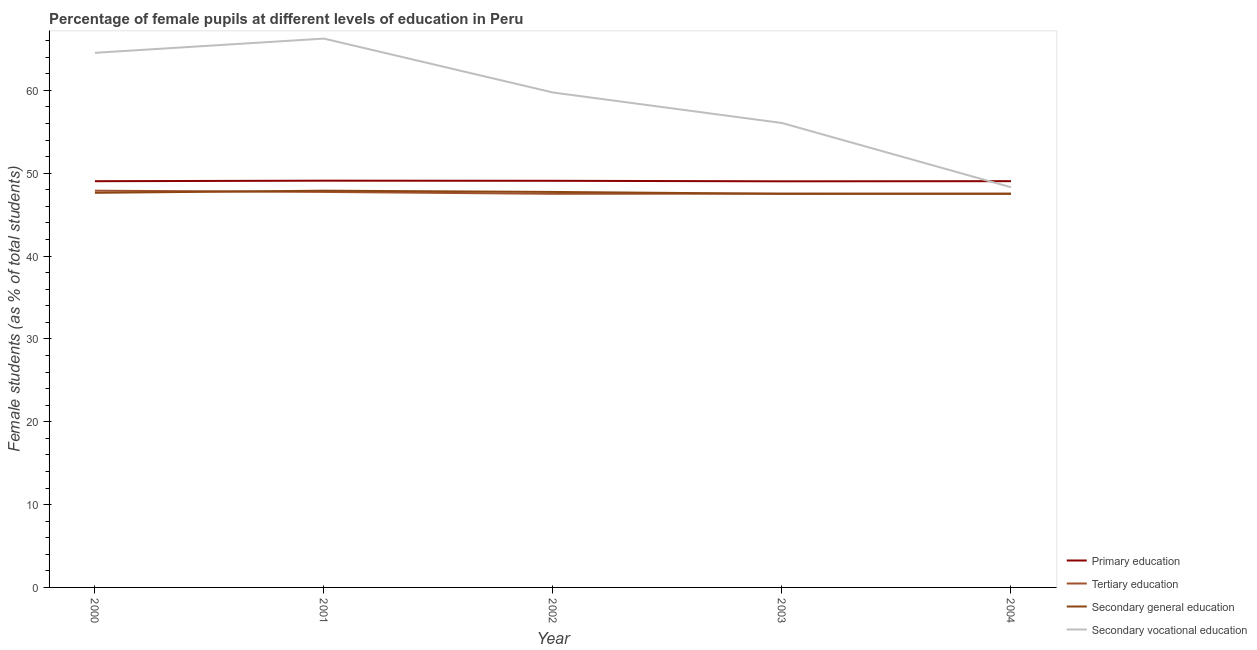What is the percentage of female students in primary education in 2003?
Keep it short and to the point. 49.02. Across all years, what is the maximum percentage of female students in secondary education?
Your answer should be compact. 47.89. Across all years, what is the minimum percentage of female students in tertiary education?
Your answer should be compact. 47.5. In which year was the percentage of female students in tertiary education maximum?
Offer a very short reply. 2000. What is the total percentage of female students in secondary education in the graph?
Provide a succinct answer. 238.3. What is the difference between the percentage of female students in secondary education in 2000 and that in 2003?
Make the answer very short. 0.12. What is the difference between the percentage of female students in tertiary education in 2000 and the percentage of female students in secondary vocational education in 2001?
Your answer should be compact. -18.36. What is the average percentage of female students in tertiary education per year?
Your response must be concise. 47.63. In the year 2002, what is the difference between the percentage of female students in secondary education and percentage of female students in secondary vocational education?
Your answer should be very brief. -12. What is the ratio of the percentage of female students in secondary education in 2001 to that in 2004?
Make the answer very short. 1.01. Is the percentage of female students in secondary education in 2001 less than that in 2002?
Keep it short and to the point. No. Is the difference between the percentage of female students in secondary education in 2001 and 2002 greater than the difference between the percentage of female students in primary education in 2001 and 2002?
Give a very brief answer. Yes. What is the difference between the highest and the second highest percentage of female students in secondary vocational education?
Your answer should be compact. 1.72. What is the difference between the highest and the lowest percentage of female students in secondary vocational education?
Offer a terse response. 17.95. Is it the case that in every year, the sum of the percentage of female students in secondary vocational education and percentage of female students in primary education is greater than the sum of percentage of female students in tertiary education and percentage of female students in secondary education?
Offer a terse response. No. Is the percentage of female students in primary education strictly greater than the percentage of female students in secondary education over the years?
Provide a succinct answer. Yes. How many years are there in the graph?
Offer a terse response. 5. What is the difference between two consecutive major ticks on the Y-axis?
Give a very brief answer. 10. Are the values on the major ticks of Y-axis written in scientific E-notation?
Your answer should be very brief. No. Does the graph contain any zero values?
Offer a terse response. No. How many legend labels are there?
Provide a short and direct response. 4. What is the title of the graph?
Give a very brief answer. Percentage of female pupils at different levels of education in Peru. Does "Interest Payments" appear as one of the legend labels in the graph?
Offer a terse response. No. What is the label or title of the Y-axis?
Your answer should be compact. Female students (as % of total students). What is the Female students (as % of total students) in Primary education in 2000?
Your response must be concise. 49.03. What is the Female students (as % of total students) of Tertiary education in 2000?
Offer a terse response. 47.89. What is the Female students (as % of total students) in Secondary general education in 2000?
Ensure brevity in your answer.  47.63. What is the Female students (as % of total students) of Secondary vocational education in 2000?
Offer a terse response. 64.53. What is the Female students (as % of total students) in Primary education in 2001?
Keep it short and to the point. 49.1. What is the Female students (as % of total students) in Tertiary education in 2001?
Your response must be concise. 47.74. What is the Female students (as % of total students) in Secondary general education in 2001?
Make the answer very short. 47.89. What is the Female students (as % of total students) in Secondary vocational education in 2001?
Your response must be concise. 66.25. What is the Female students (as % of total students) in Primary education in 2002?
Ensure brevity in your answer.  49.08. What is the Female students (as % of total students) in Tertiary education in 2002?
Your response must be concise. 47.51. What is the Female students (as % of total students) in Secondary general education in 2002?
Keep it short and to the point. 47.74. What is the Female students (as % of total students) of Secondary vocational education in 2002?
Provide a short and direct response. 59.74. What is the Female students (as % of total students) in Primary education in 2003?
Offer a very short reply. 49.02. What is the Female students (as % of total students) in Tertiary education in 2003?
Provide a succinct answer. 47.53. What is the Female students (as % of total students) in Secondary general education in 2003?
Your response must be concise. 47.51. What is the Female students (as % of total students) of Secondary vocational education in 2003?
Offer a very short reply. 56.06. What is the Female students (as % of total students) in Primary education in 2004?
Offer a terse response. 49.04. What is the Female students (as % of total students) of Tertiary education in 2004?
Offer a terse response. 47.5. What is the Female students (as % of total students) in Secondary general education in 2004?
Ensure brevity in your answer.  47.53. What is the Female students (as % of total students) in Secondary vocational education in 2004?
Provide a short and direct response. 48.3. Across all years, what is the maximum Female students (as % of total students) of Primary education?
Keep it short and to the point. 49.1. Across all years, what is the maximum Female students (as % of total students) of Tertiary education?
Your response must be concise. 47.89. Across all years, what is the maximum Female students (as % of total students) of Secondary general education?
Provide a short and direct response. 47.89. Across all years, what is the maximum Female students (as % of total students) of Secondary vocational education?
Your answer should be compact. 66.25. Across all years, what is the minimum Female students (as % of total students) in Primary education?
Your answer should be very brief. 49.02. Across all years, what is the minimum Female students (as % of total students) of Tertiary education?
Your answer should be compact. 47.5. Across all years, what is the minimum Female students (as % of total students) of Secondary general education?
Ensure brevity in your answer.  47.51. Across all years, what is the minimum Female students (as % of total students) of Secondary vocational education?
Keep it short and to the point. 48.3. What is the total Female students (as % of total students) of Primary education in the graph?
Provide a succinct answer. 245.27. What is the total Female students (as % of total students) in Tertiary education in the graph?
Ensure brevity in your answer.  238.17. What is the total Female students (as % of total students) in Secondary general education in the graph?
Give a very brief answer. 238.3. What is the total Female students (as % of total students) in Secondary vocational education in the graph?
Your answer should be compact. 294.88. What is the difference between the Female students (as % of total students) in Primary education in 2000 and that in 2001?
Provide a short and direct response. -0.06. What is the difference between the Female students (as % of total students) of Tertiary education in 2000 and that in 2001?
Offer a very short reply. 0.15. What is the difference between the Female students (as % of total students) in Secondary general education in 2000 and that in 2001?
Make the answer very short. -0.26. What is the difference between the Female students (as % of total students) in Secondary vocational education in 2000 and that in 2001?
Provide a short and direct response. -1.72. What is the difference between the Female students (as % of total students) in Primary education in 2000 and that in 2002?
Make the answer very short. -0.05. What is the difference between the Female students (as % of total students) of Tertiary education in 2000 and that in 2002?
Offer a terse response. 0.38. What is the difference between the Female students (as % of total students) of Secondary general education in 2000 and that in 2002?
Keep it short and to the point. -0.11. What is the difference between the Female students (as % of total students) in Secondary vocational education in 2000 and that in 2002?
Make the answer very short. 4.79. What is the difference between the Female students (as % of total students) in Primary education in 2000 and that in 2003?
Offer a very short reply. 0.01. What is the difference between the Female students (as % of total students) of Tertiary education in 2000 and that in 2003?
Keep it short and to the point. 0.36. What is the difference between the Female students (as % of total students) in Secondary general education in 2000 and that in 2003?
Give a very brief answer. 0.12. What is the difference between the Female students (as % of total students) in Secondary vocational education in 2000 and that in 2003?
Your answer should be compact. 8.47. What is the difference between the Female students (as % of total students) of Primary education in 2000 and that in 2004?
Give a very brief answer. -0. What is the difference between the Female students (as % of total students) in Tertiary education in 2000 and that in 2004?
Make the answer very short. 0.38. What is the difference between the Female students (as % of total students) of Secondary general education in 2000 and that in 2004?
Give a very brief answer. 0.1. What is the difference between the Female students (as % of total students) of Secondary vocational education in 2000 and that in 2004?
Provide a short and direct response. 16.23. What is the difference between the Female students (as % of total students) of Primary education in 2001 and that in 2002?
Give a very brief answer. 0.01. What is the difference between the Female students (as % of total students) of Tertiary education in 2001 and that in 2002?
Offer a very short reply. 0.23. What is the difference between the Female students (as % of total students) of Secondary general education in 2001 and that in 2002?
Provide a short and direct response. 0.15. What is the difference between the Female students (as % of total students) in Secondary vocational education in 2001 and that in 2002?
Ensure brevity in your answer.  6.51. What is the difference between the Female students (as % of total students) in Primary education in 2001 and that in 2003?
Offer a terse response. 0.08. What is the difference between the Female students (as % of total students) of Tertiary education in 2001 and that in 2003?
Your answer should be very brief. 0.21. What is the difference between the Female students (as % of total students) in Secondary general education in 2001 and that in 2003?
Give a very brief answer. 0.38. What is the difference between the Female students (as % of total students) of Secondary vocational education in 2001 and that in 2003?
Give a very brief answer. 10.19. What is the difference between the Female students (as % of total students) of Primary education in 2001 and that in 2004?
Provide a short and direct response. 0.06. What is the difference between the Female students (as % of total students) in Tertiary education in 2001 and that in 2004?
Your answer should be compact. 0.23. What is the difference between the Female students (as % of total students) in Secondary general education in 2001 and that in 2004?
Your answer should be very brief. 0.36. What is the difference between the Female students (as % of total students) of Secondary vocational education in 2001 and that in 2004?
Offer a terse response. 17.95. What is the difference between the Female students (as % of total students) of Primary education in 2002 and that in 2003?
Your answer should be very brief. 0.06. What is the difference between the Female students (as % of total students) of Tertiary education in 2002 and that in 2003?
Keep it short and to the point. -0.02. What is the difference between the Female students (as % of total students) of Secondary general education in 2002 and that in 2003?
Offer a very short reply. 0.23. What is the difference between the Female students (as % of total students) in Secondary vocational education in 2002 and that in 2003?
Your answer should be compact. 3.68. What is the difference between the Female students (as % of total students) in Primary education in 2002 and that in 2004?
Provide a short and direct response. 0.05. What is the difference between the Female students (as % of total students) of Tertiary education in 2002 and that in 2004?
Offer a terse response. 0.01. What is the difference between the Female students (as % of total students) in Secondary general education in 2002 and that in 2004?
Your answer should be compact. 0.21. What is the difference between the Female students (as % of total students) of Secondary vocational education in 2002 and that in 2004?
Your response must be concise. 11.44. What is the difference between the Female students (as % of total students) in Primary education in 2003 and that in 2004?
Keep it short and to the point. -0.02. What is the difference between the Female students (as % of total students) in Tertiary education in 2003 and that in 2004?
Your answer should be very brief. 0.03. What is the difference between the Female students (as % of total students) in Secondary general education in 2003 and that in 2004?
Offer a very short reply. -0.02. What is the difference between the Female students (as % of total students) of Secondary vocational education in 2003 and that in 2004?
Ensure brevity in your answer.  7.76. What is the difference between the Female students (as % of total students) in Primary education in 2000 and the Female students (as % of total students) in Tertiary education in 2001?
Your answer should be very brief. 1.3. What is the difference between the Female students (as % of total students) in Primary education in 2000 and the Female students (as % of total students) in Secondary general education in 2001?
Your answer should be compact. 1.15. What is the difference between the Female students (as % of total students) in Primary education in 2000 and the Female students (as % of total students) in Secondary vocational education in 2001?
Your response must be concise. -17.21. What is the difference between the Female students (as % of total students) of Tertiary education in 2000 and the Female students (as % of total students) of Secondary vocational education in 2001?
Your response must be concise. -18.36. What is the difference between the Female students (as % of total students) of Secondary general education in 2000 and the Female students (as % of total students) of Secondary vocational education in 2001?
Your response must be concise. -18.62. What is the difference between the Female students (as % of total students) of Primary education in 2000 and the Female students (as % of total students) of Tertiary education in 2002?
Provide a short and direct response. 1.52. What is the difference between the Female students (as % of total students) in Primary education in 2000 and the Female students (as % of total students) in Secondary general education in 2002?
Provide a succinct answer. 1.3. What is the difference between the Female students (as % of total students) of Primary education in 2000 and the Female students (as % of total students) of Secondary vocational education in 2002?
Give a very brief answer. -10.71. What is the difference between the Female students (as % of total students) in Tertiary education in 2000 and the Female students (as % of total students) in Secondary general education in 2002?
Offer a terse response. 0.15. What is the difference between the Female students (as % of total students) of Tertiary education in 2000 and the Female students (as % of total students) of Secondary vocational education in 2002?
Make the answer very short. -11.85. What is the difference between the Female students (as % of total students) in Secondary general education in 2000 and the Female students (as % of total students) in Secondary vocational education in 2002?
Your answer should be compact. -12.11. What is the difference between the Female students (as % of total students) of Primary education in 2000 and the Female students (as % of total students) of Tertiary education in 2003?
Your answer should be very brief. 1.5. What is the difference between the Female students (as % of total students) in Primary education in 2000 and the Female students (as % of total students) in Secondary general education in 2003?
Provide a short and direct response. 1.52. What is the difference between the Female students (as % of total students) in Primary education in 2000 and the Female students (as % of total students) in Secondary vocational education in 2003?
Provide a succinct answer. -7.03. What is the difference between the Female students (as % of total students) of Tertiary education in 2000 and the Female students (as % of total students) of Secondary general education in 2003?
Provide a short and direct response. 0.38. What is the difference between the Female students (as % of total students) in Tertiary education in 2000 and the Female students (as % of total students) in Secondary vocational education in 2003?
Ensure brevity in your answer.  -8.17. What is the difference between the Female students (as % of total students) of Secondary general education in 2000 and the Female students (as % of total students) of Secondary vocational education in 2003?
Offer a very short reply. -8.43. What is the difference between the Female students (as % of total students) of Primary education in 2000 and the Female students (as % of total students) of Tertiary education in 2004?
Make the answer very short. 1.53. What is the difference between the Female students (as % of total students) of Primary education in 2000 and the Female students (as % of total students) of Secondary general education in 2004?
Provide a short and direct response. 1.5. What is the difference between the Female students (as % of total students) of Primary education in 2000 and the Female students (as % of total students) of Secondary vocational education in 2004?
Give a very brief answer. 0.73. What is the difference between the Female students (as % of total students) in Tertiary education in 2000 and the Female students (as % of total students) in Secondary general education in 2004?
Ensure brevity in your answer.  0.36. What is the difference between the Female students (as % of total students) of Tertiary education in 2000 and the Female students (as % of total students) of Secondary vocational education in 2004?
Provide a succinct answer. -0.41. What is the difference between the Female students (as % of total students) of Secondary general education in 2000 and the Female students (as % of total students) of Secondary vocational education in 2004?
Your answer should be compact. -0.67. What is the difference between the Female students (as % of total students) in Primary education in 2001 and the Female students (as % of total students) in Tertiary education in 2002?
Provide a succinct answer. 1.59. What is the difference between the Female students (as % of total students) of Primary education in 2001 and the Female students (as % of total students) of Secondary general education in 2002?
Ensure brevity in your answer.  1.36. What is the difference between the Female students (as % of total students) in Primary education in 2001 and the Female students (as % of total students) in Secondary vocational education in 2002?
Your answer should be very brief. -10.64. What is the difference between the Female students (as % of total students) in Tertiary education in 2001 and the Female students (as % of total students) in Secondary general education in 2002?
Your response must be concise. 0. What is the difference between the Female students (as % of total students) in Tertiary education in 2001 and the Female students (as % of total students) in Secondary vocational education in 2002?
Your response must be concise. -12. What is the difference between the Female students (as % of total students) in Secondary general education in 2001 and the Female students (as % of total students) in Secondary vocational education in 2002?
Ensure brevity in your answer.  -11.85. What is the difference between the Female students (as % of total students) of Primary education in 2001 and the Female students (as % of total students) of Tertiary education in 2003?
Make the answer very short. 1.56. What is the difference between the Female students (as % of total students) of Primary education in 2001 and the Female students (as % of total students) of Secondary general education in 2003?
Provide a succinct answer. 1.59. What is the difference between the Female students (as % of total students) in Primary education in 2001 and the Female students (as % of total students) in Secondary vocational education in 2003?
Make the answer very short. -6.96. What is the difference between the Female students (as % of total students) in Tertiary education in 2001 and the Female students (as % of total students) in Secondary general education in 2003?
Ensure brevity in your answer.  0.23. What is the difference between the Female students (as % of total students) of Tertiary education in 2001 and the Female students (as % of total students) of Secondary vocational education in 2003?
Your response must be concise. -8.32. What is the difference between the Female students (as % of total students) in Secondary general education in 2001 and the Female students (as % of total students) in Secondary vocational education in 2003?
Your answer should be very brief. -8.17. What is the difference between the Female students (as % of total students) of Primary education in 2001 and the Female students (as % of total students) of Tertiary education in 2004?
Your answer should be very brief. 1.59. What is the difference between the Female students (as % of total students) of Primary education in 2001 and the Female students (as % of total students) of Secondary general education in 2004?
Provide a succinct answer. 1.56. What is the difference between the Female students (as % of total students) of Primary education in 2001 and the Female students (as % of total students) of Secondary vocational education in 2004?
Offer a very short reply. 0.79. What is the difference between the Female students (as % of total students) of Tertiary education in 2001 and the Female students (as % of total students) of Secondary general education in 2004?
Ensure brevity in your answer.  0.21. What is the difference between the Female students (as % of total students) of Tertiary education in 2001 and the Female students (as % of total students) of Secondary vocational education in 2004?
Make the answer very short. -0.56. What is the difference between the Female students (as % of total students) of Secondary general education in 2001 and the Female students (as % of total students) of Secondary vocational education in 2004?
Offer a terse response. -0.41. What is the difference between the Female students (as % of total students) in Primary education in 2002 and the Female students (as % of total students) in Tertiary education in 2003?
Ensure brevity in your answer.  1.55. What is the difference between the Female students (as % of total students) in Primary education in 2002 and the Female students (as % of total students) in Secondary general education in 2003?
Provide a succinct answer. 1.57. What is the difference between the Female students (as % of total students) of Primary education in 2002 and the Female students (as % of total students) of Secondary vocational education in 2003?
Give a very brief answer. -6.98. What is the difference between the Female students (as % of total students) of Tertiary education in 2002 and the Female students (as % of total students) of Secondary vocational education in 2003?
Your response must be concise. -8.55. What is the difference between the Female students (as % of total students) of Secondary general education in 2002 and the Female students (as % of total students) of Secondary vocational education in 2003?
Provide a succinct answer. -8.32. What is the difference between the Female students (as % of total students) in Primary education in 2002 and the Female students (as % of total students) in Tertiary education in 2004?
Your response must be concise. 1.58. What is the difference between the Female students (as % of total students) of Primary education in 2002 and the Female students (as % of total students) of Secondary general education in 2004?
Give a very brief answer. 1.55. What is the difference between the Female students (as % of total students) in Primary education in 2002 and the Female students (as % of total students) in Secondary vocational education in 2004?
Your answer should be very brief. 0.78. What is the difference between the Female students (as % of total students) in Tertiary education in 2002 and the Female students (as % of total students) in Secondary general education in 2004?
Provide a short and direct response. -0.02. What is the difference between the Female students (as % of total students) of Tertiary education in 2002 and the Female students (as % of total students) of Secondary vocational education in 2004?
Give a very brief answer. -0.79. What is the difference between the Female students (as % of total students) of Secondary general education in 2002 and the Female students (as % of total students) of Secondary vocational education in 2004?
Offer a very short reply. -0.56. What is the difference between the Female students (as % of total students) of Primary education in 2003 and the Female students (as % of total students) of Tertiary education in 2004?
Provide a short and direct response. 1.52. What is the difference between the Female students (as % of total students) of Primary education in 2003 and the Female students (as % of total students) of Secondary general education in 2004?
Make the answer very short. 1.49. What is the difference between the Female students (as % of total students) of Primary education in 2003 and the Female students (as % of total students) of Secondary vocational education in 2004?
Make the answer very short. 0.72. What is the difference between the Female students (as % of total students) in Tertiary education in 2003 and the Female students (as % of total students) in Secondary general education in 2004?
Provide a short and direct response. 0. What is the difference between the Female students (as % of total students) of Tertiary education in 2003 and the Female students (as % of total students) of Secondary vocational education in 2004?
Your response must be concise. -0.77. What is the difference between the Female students (as % of total students) of Secondary general education in 2003 and the Female students (as % of total students) of Secondary vocational education in 2004?
Provide a short and direct response. -0.79. What is the average Female students (as % of total students) of Primary education per year?
Offer a terse response. 49.05. What is the average Female students (as % of total students) of Tertiary education per year?
Make the answer very short. 47.63. What is the average Female students (as % of total students) of Secondary general education per year?
Your response must be concise. 47.66. What is the average Female students (as % of total students) in Secondary vocational education per year?
Offer a terse response. 58.98. In the year 2000, what is the difference between the Female students (as % of total students) in Primary education and Female students (as % of total students) in Tertiary education?
Ensure brevity in your answer.  1.15. In the year 2000, what is the difference between the Female students (as % of total students) in Primary education and Female students (as % of total students) in Secondary general education?
Offer a terse response. 1.4. In the year 2000, what is the difference between the Female students (as % of total students) in Primary education and Female students (as % of total students) in Secondary vocational education?
Ensure brevity in your answer.  -15.5. In the year 2000, what is the difference between the Female students (as % of total students) of Tertiary education and Female students (as % of total students) of Secondary general education?
Your response must be concise. 0.26. In the year 2000, what is the difference between the Female students (as % of total students) of Tertiary education and Female students (as % of total students) of Secondary vocational education?
Ensure brevity in your answer.  -16.64. In the year 2000, what is the difference between the Female students (as % of total students) in Secondary general education and Female students (as % of total students) in Secondary vocational education?
Offer a terse response. -16.9. In the year 2001, what is the difference between the Female students (as % of total students) of Primary education and Female students (as % of total students) of Tertiary education?
Your answer should be compact. 1.36. In the year 2001, what is the difference between the Female students (as % of total students) in Primary education and Female students (as % of total students) in Secondary general education?
Provide a succinct answer. 1.21. In the year 2001, what is the difference between the Female students (as % of total students) of Primary education and Female students (as % of total students) of Secondary vocational education?
Provide a short and direct response. -17.15. In the year 2001, what is the difference between the Female students (as % of total students) in Tertiary education and Female students (as % of total students) in Secondary general education?
Your answer should be very brief. -0.15. In the year 2001, what is the difference between the Female students (as % of total students) of Tertiary education and Female students (as % of total students) of Secondary vocational education?
Give a very brief answer. -18.51. In the year 2001, what is the difference between the Female students (as % of total students) in Secondary general education and Female students (as % of total students) in Secondary vocational education?
Ensure brevity in your answer.  -18.36. In the year 2002, what is the difference between the Female students (as % of total students) of Primary education and Female students (as % of total students) of Tertiary education?
Provide a succinct answer. 1.57. In the year 2002, what is the difference between the Female students (as % of total students) of Primary education and Female students (as % of total students) of Secondary general education?
Make the answer very short. 1.35. In the year 2002, what is the difference between the Female students (as % of total students) of Primary education and Female students (as % of total students) of Secondary vocational education?
Your answer should be compact. -10.66. In the year 2002, what is the difference between the Female students (as % of total students) in Tertiary education and Female students (as % of total students) in Secondary general education?
Keep it short and to the point. -0.23. In the year 2002, what is the difference between the Female students (as % of total students) of Tertiary education and Female students (as % of total students) of Secondary vocational education?
Provide a short and direct response. -12.23. In the year 2002, what is the difference between the Female students (as % of total students) of Secondary general education and Female students (as % of total students) of Secondary vocational education?
Make the answer very short. -12. In the year 2003, what is the difference between the Female students (as % of total students) in Primary education and Female students (as % of total students) in Tertiary education?
Make the answer very short. 1.49. In the year 2003, what is the difference between the Female students (as % of total students) in Primary education and Female students (as % of total students) in Secondary general education?
Offer a terse response. 1.51. In the year 2003, what is the difference between the Female students (as % of total students) of Primary education and Female students (as % of total students) of Secondary vocational education?
Offer a terse response. -7.04. In the year 2003, what is the difference between the Female students (as % of total students) in Tertiary education and Female students (as % of total students) in Secondary general education?
Your answer should be very brief. 0.02. In the year 2003, what is the difference between the Female students (as % of total students) of Tertiary education and Female students (as % of total students) of Secondary vocational education?
Your response must be concise. -8.53. In the year 2003, what is the difference between the Female students (as % of total students) of Secondary general education and Female students (as % of total students) of Secondary vocational education?
Provide a succinct answer. -8.55. In the year 2004, what is the difference between the Female students (as % of total students) of Primary education and Female students (as % of total students) of Tertiary education?
Your response must be concise. 1.53. In the year 2004, what is the difference between the Female students (as % of total students) of Primary education and Female students (as % of total students) of Secondary general education?
Make the answer very short. 1.5. In the year 2004, what is the difference between the Female students (as % of total students) in Primary education and Female students (as % of total students) in Secondary vocational education?
Offer a terse response. 0.73. In the year 2004, what is the difference between the Female students (as % of total students) in Tertiary education and Female students (as % of total students) in Secondary general education?
Offer a terse response. -0.03. In the year 2004, what is the difference between the Female students (as % of total students) of Tertiary education and Female students (as % of total students) of Secondary vocational education?
Your answer should be very brief. -0.8. In the year 2004, what is the difference between the Female students (as % of total students) in Secondary general education and Female students (as % of total students) in Secondary vocational education?
Your answer should be compact. -0.77. What is the ratio of the Female students (as % of total students) of Secondary general education in 2000 to that in 2001?
Give a very brief answer. 0.99. What is the ratio of the Female students (as % of total students) of Secondary vocational education in 2000 to that in 2001?
Provide a short and direct response. 0.97. What is the ratio of the Female students (as % of total students) in Primary education in 2000 to that in 2002?
Your response must be concise. 1. What is the ratio of the Female students (as % of total students) of Tertiary education in 2000 to that in 2002?
Make the answer very short. 1.01. What is the ratio of the Female students (as % of total students) of Secondary general education in 2000 to that in 2002?
Make the answer very short. 1. What is the ratio of the Female students (as % of total students) in Secondary vocational education in 2000 to that in 2002?
Offer a very short reply. 1.08. What is the ratio of the Female students (as % of total students) in Tertiary education in 2000 to that in 2003?
Provide a succinct answer. 1.01. What is the ratio of the Female students (as % of total students) of Secondary vocational education in 2000 to that in 2003?
Your answer should be very brief. 1.15. What is the ratio of the Female students (as % of total students) in Tertiary education in 2000 to that in 2004?
Ensure brevity in your answer.  1.01. What is the ratio of the Female students (as % of total students) of Secondary general education in 2000 to that in 2004?
Offer a terse response. 1. What is the ratio of the Female students (as % of total students) of Secondary vocational education in 2000 to that in 2004?
Provide a short and direct response. 1.34. What is the ratio of the Female students (as % of total students) of Secondary general education in 2001 to that in 2002?
Provide a succinct answer. 1. What is the ratio of the Female students (as % of total students) in Secondary vocational education in 2001 to that in 2002?
Make the answer very short. 1.11. What is the ratio of the Female students (as % of total students) in Primary education in 2001 to that in 2003?
Provide a succinct answer. 1. What is the ratio of the Female students (as % of total students) of Secondary general education in 2001 to that in 2003?
Your response must be concise. 1.01. What is the ratio of the Female students (as % of total students) in Secondary vocational education in 2001 to that in 2003?
Your answer should be very brief. 1.18. What is the ratio of the Female students (as % of total students) in Primary education in 2001 to that in 2004?
Offer a very short reply. 1. What is the ratio of the Female students (as % of total students) of Tertiary education in 2001 to that in 2004?
Give a very brief answer. 1. What is the ratio of the Female students (as % of total students) in Secondary general education in 2001 to that in 2004?
Your answer should be compact. 1.01. What is the ratio of the Female students (as % of total students) in Secondary vocational education in 2001 to that in 2004?
Make the answer very short. 1.37. What is the ratio of the Female students (as % of total students) of Primary education in 2002 to that in 2003?
Ensure brevity in your answer.  1. What is the ratio of the Female students (as % of total students) in Tertiary education in 2002 to that in 2003?
Offer a very short reply. 1. What is the ratio of the Female students (as % of total students) of Secondary general education in 2002 to that in 2003?
Ensure brevity in your answer.  1. What is the ratio of the Female students (as % of total students) of Secondary vocational education in 2002 to that in 2003?
Your answer should be very brief. 1.07. What is the ratio of the Female students (as % of total students) in Primary education in 2002 to that in 2004?
Your answer should be compact. 1. What is the ratio of the Female students (as % of total students) in Secondary general education in 2002 to that in 2004?
Offer a terse response. 1. What is the ratio of the Female students (as % of total students) in Secondary vocational education in 2002 to that in 2004?
Provide a short and direct response. 1.24. What is the ratio of the Female students (as % of total students) in Primary education in 2003 to that in 2004?
Give a very brief answer. 1. What is the ratio of the Female students (as % of total students) in Tertiary education in 2003 to that in 2004?
Provide a short and direct response. 1. What is the ratio of the Female students (as % of total students) of Secondary general education in 2003 to that in 2004?
Your answer should be very brief. 1. What is the ratio of the Female students (as % of total students) of Secondary vocational education in 2003 to that in 2004?
Give a very brief answer. 1.16. What is the difference between the highest and the second highest Female students (as % of total students) in Primary education?
Give a very brief answer. 0.01. What is the difference between the highest and the second highest Female students (as % of total students) of Tertiary education?
Make the answer very short. 0.15. What is the difference between the highest and the second highest Female students (as % of total students) of Secondary general education?
Keep it short and to the point. 0.15. What is the difference between the highest and the second highest Female students (as % of total students) in Secondary vocational education?
Keep it short and to the point. 1.72. What is the difference between the highest and the lowest Female students (as % of total students) in Primary education?
Provide a succinct answer. 0.08. What is the difference between the highest and the lowest Female students (as % of total students) of Tertiary education?
Your answer should be compact. 0.38. What is the difference between the highest and the lowest Female students (as % of total students) of Secondary general education?
Provide a succinct answer. 0.38. What is the difference between the highest and the lowest Female students (as % of total students) in Secondary vocational education?
Your response must be concise. 17.95. 